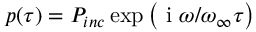Convert formula to latex. <formula><loc_0><loc_0><loc_500><loc_500>p ( \tau ) = P _ { i n c } \exp \left ( i \omega / \omega _ { \infty } \tau \right )</formula> 